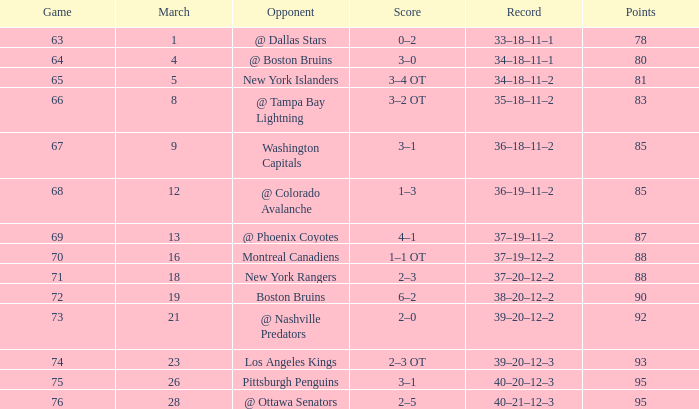Which points include an adversary of new york islanders and a game under 65? None. 